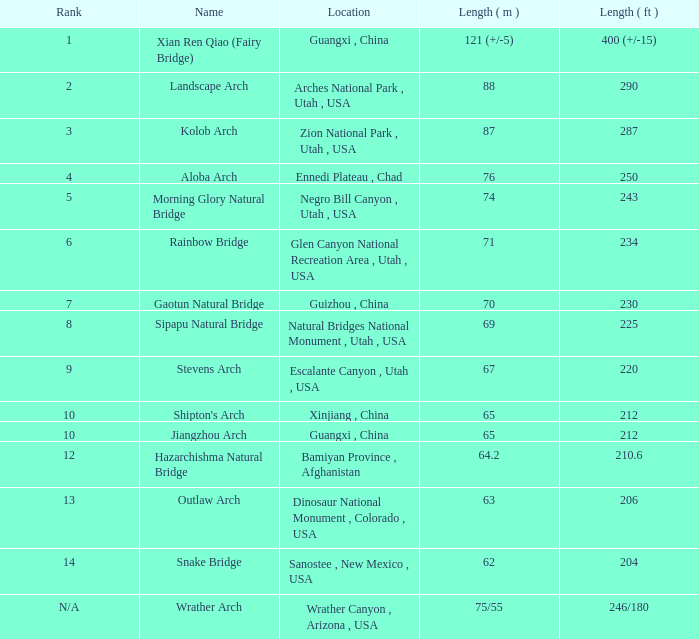Where is the longest arch with a length in meters of 63? Dinosaur National Monument , Colorado , USA. 